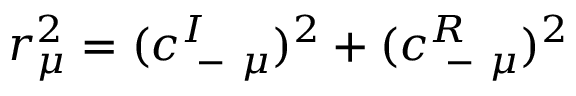Convert formula to latex. <formula><loc_0><loc_0><loc_500><loc_500>r _ { \mu } ^ { 2 } = ( c _ { - \mu } ^ { I } ) ^ { 2 } + ( c _ { - \mu } ^ { R } ) ^ { 2 }</formula> 